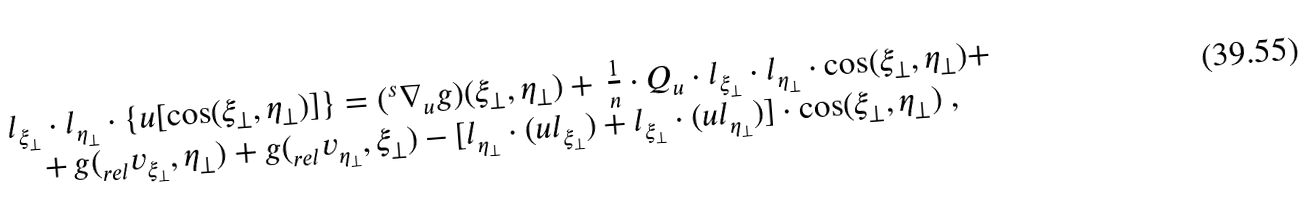<formula> <loc_0><loc_0><loc_500><loc_500>\begin{array} { c } l _ { \xi _ { \perp } } \cdot l _ { \eta _ { \perp } } \cdot \{ u [ \cos ( \xi _ { \perp } , \eta _ { \perp } ) ] \} = ( ^ { s } \nabla _ { u } g ) ( \xi _ { \perp } , \eta _ { \perp } ) + \, \frac { 1 } { n } \cdot Q _ { u } \cdot l _ { \xi _ { \perp } } \cdot l _ { \eta _ { \perp } } \cdot \cos ( \xi _ { \perp } , \eta _ { \perp } ) + \\ + \, g ( _ { r e l } v _ { \xi _ { \perp } } , \eta _ { \perp } ) + g ( _ { r e l } v _ { \eta _ { \perp } } , \xi _ { \perp } ) - [ l _ { \eta _ { \perp } } \cdot ( u l _ { \xi _ { \perp } } ) + l _ { \xi _ { \perp } } \cdot ( u l _ { \eta _ { \perp } } ) ] \cdot \cos ( \xi _ { \perp } , \eta _ { \perp } ) \text { ,} \end{array}</formula> 